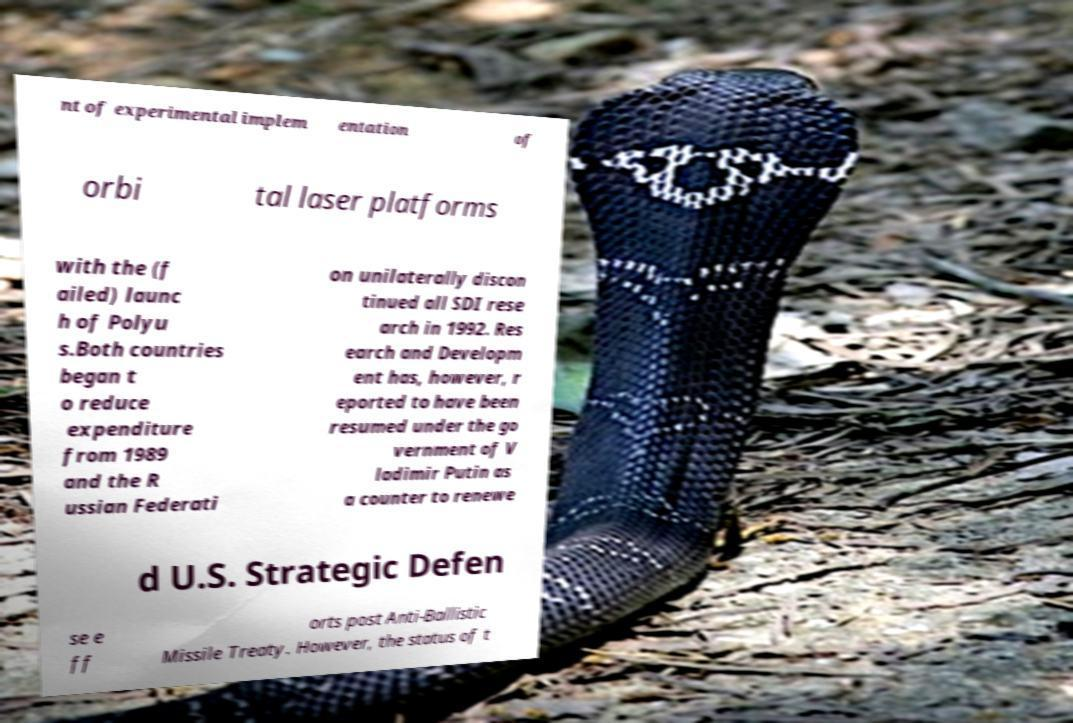Could you assist in decoding the text presented in this image and type it out clearly? nt of experimental implem entation of orbi tal laser platforms with the (f ailed) launc h of Polyu s.Both countries began t o reduce expenditure from 1989 and the R ussian Federati on unilaterally discon tinued all SDI rese arch in 1992. Res earch and Developm ent has, however, r eported to have been resumed under the go vernment of V ladimir Putin as a counter to renewe d U.S. Strategic Defen se e ff orts post Anti-Ballistic Missile Treaty. However, the status of t 